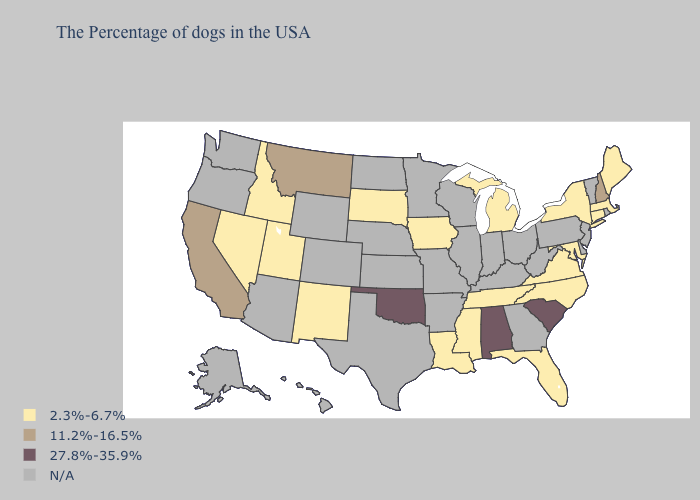Does Oklahoma have the highest value in the USA?
Quick response, please. Yes. Name the states that have a value in the range 27.8%-35.9%?
Keep it brief. South Carolina, Alabama, Oklahoma. How many symbols are there in the legend?
Keep it brief. 4. What is the value of Texas?
Answer briefly. N/A. Name the states that have a value in the range 2.3%-6.7%?
Keep it brief. Maine, Massachusetts, Connecticut, New York, Maryland, Virginia, North Carolina, Florida, Michigan, Tennessee, Mississippi, Louisiana, Iowa, South Dakota, New Mexico, Utah, Idaho, Nevada. How many symbols are there in the legend?
Quick response, please. 4. Name the states that have a value in the range 27.8%-35.9%?
Concise answer only. South Carolina, Alabama, Oklahoma. How many symbols are there in the legend?
Short answer required. 4. Among the states that border Idaho , which have the lowest value?
Short answer required. Utah, Nevada. Name the states that have a value in the range N/A?
Short answer required. Rhode Island, Vermont, New Jersey, Delaware, Pennsylvania, West Virginia, Ohio, Georgia, Kentucky, Indiana, Wisconsin, Illinois, Missouri, Arkansas, Minnesota, Kansas, Nebraska, Texas, North Dakota, Wyoming, Colorado, Arizona, Washington, Oregon, Alaska, Hawaii. Name the states that have a value in the range 27.8%-35.9%?
Concise answer only. South Carolina, Alabama, Oklahoma. Does the first symbol in the legend represent the smallest category?
Answer briefly. Yes. 